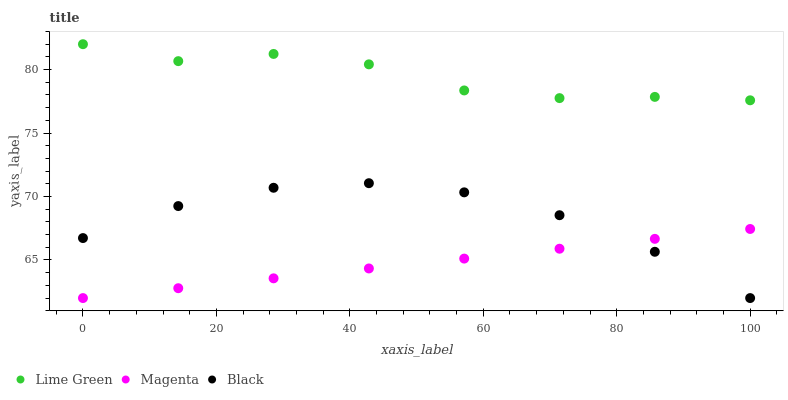Does Magenta have the minimum area under the curve?
Answer yes or no. Yes. Does Lime Green have the maximum area under the curve?
Answer yes or no. Yes. Does Lime Green have the minimum area under the curve?
Answer yes or no. No. Does Magenta have the maximum area under the curve?
Answer yes or no. No. Is Magenta the smoothest?
Answer yes or no. Yes. Is Lime Green the roughest?
Answer yes or no. Yes. Is Lime Green the smoothest?
Answer yes or no. No. Is Magenta the roughest?
Answer yes or no. No. Does Black have the lowest value?
Answer yes or no. Yes. Does Lime Green have the lowest value?
Answer yes or no. No. Does Lime Green have the highest value?
Answer yes or no. Yes. Does Magenta have the highest value?
Answer yes or no. No. Is Black less than Lime Green?
Answer yes or no. Yes. Is Lime Green greater than Magenta?
Answer yes or no. Yes. Does Black intersect Magenta?
Answer yes or no. Yes. Is Black less than Magenta?
Answer yes or no. No. Is Black greater than Magenta?
Answer yes or no. No. Does Black intersect Lime Green?
Answer yes or no. No. 